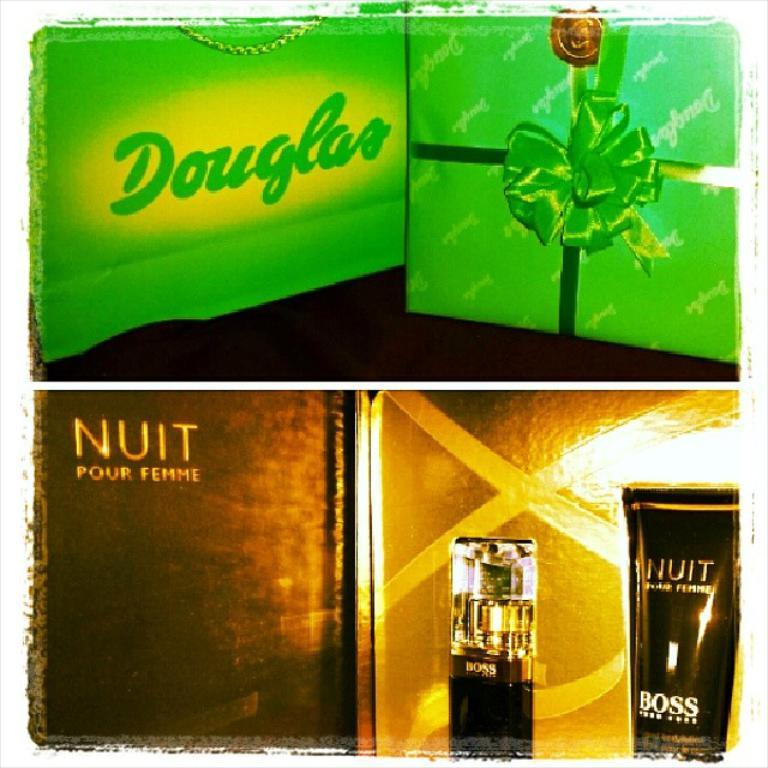<image>
Offer a succinct explanation of the picture presented. Hugo Boss Nuit perfume is shown below a green douglas sign. 